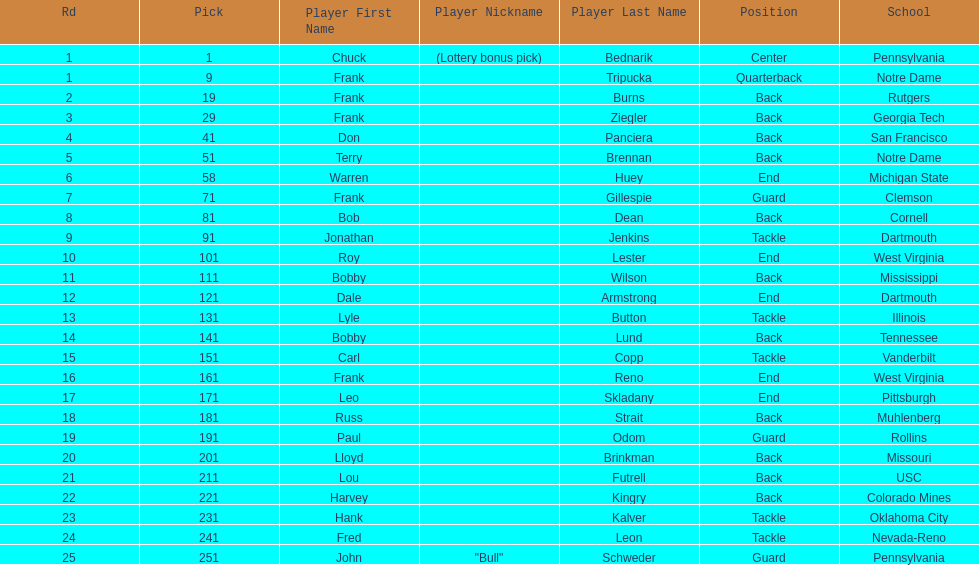What was the position that most of the players had? Back. 